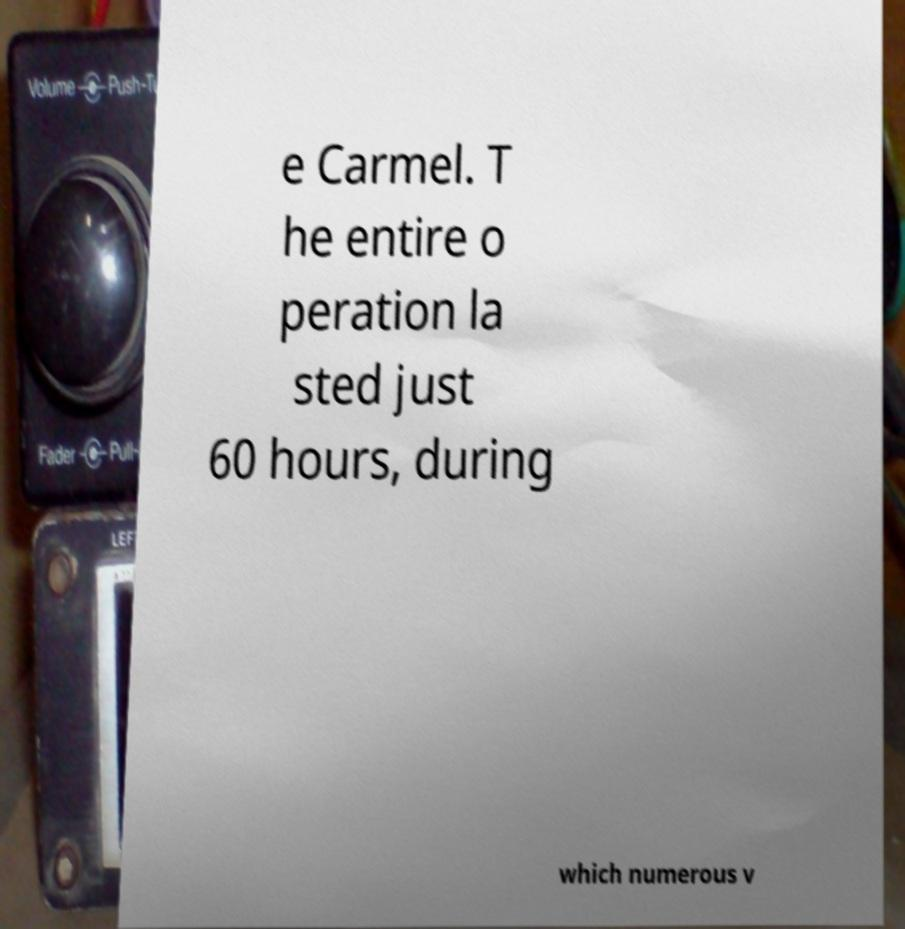What messages or text are displayed in this image? I need them in a readable, typed format. e Carmel. T he entire o peration la sted just 60 hours, during which numerous v 